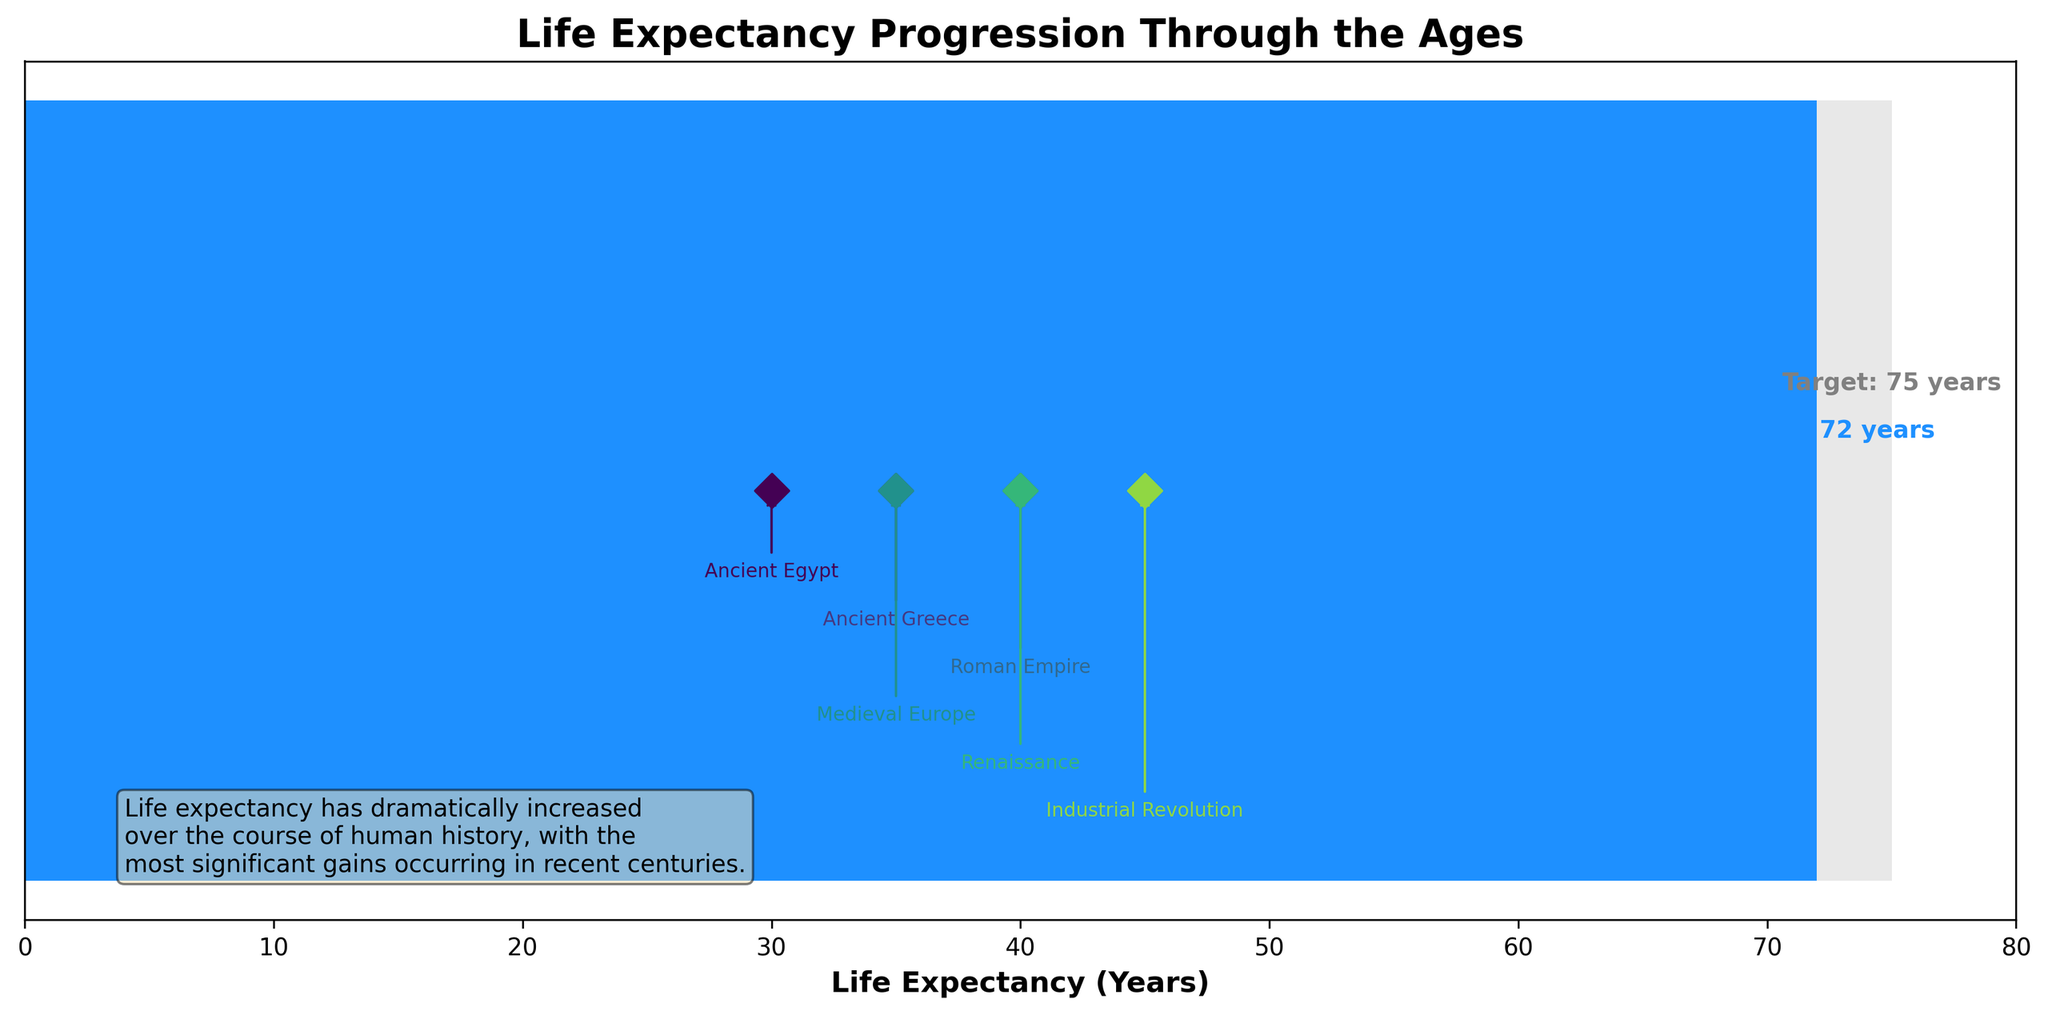What is the title of the figure? The title is located at the top of the figure, which reads "Life Expectancy Progression Through the Ages."
Answer: Life Expectancy Progression Through the Ages What is the life expectancy in the Modern Era? The Modern Era is highlighted with a blue bar, and the corresponding life expectancy value is written along the blue bar.
Answer: 72 years Which period has the highest life expectancy among the historical markers? By comparing the values marked for Ancient Egypt, Ancient Greece, Roman Empire, Medieval Europe, Renaissance, and Industrial Revolution, the highest value is seen during the Industrial Revolution.
Answer: Industrial Revolution How many historical periods are marked in the figure? The figure annotates six historical periods, indicated by different colored markers and labels along the horizontal axis.
Answer: Six What is the life expectancy target indicated in the figure? The figure uses a light grey bar to indicate the target life expectancy, and the value annotated next to this bar is 75 years.
Answer: 75 years What is the difference between the current life expectancy and the target life expectancy in the Modern Era? The current life expectancy is 72 years, and the target is 75 years. The difference is calculated by subtracting 72 from 75.
Answer: 3 years What can be inferred about the trend in life expectancy from ancient times to the modern era based on the data points? The life expectancy shows a gradual increase from ancient periods (as low as 30 years in Ancient Egypt) to modern times (72 years), indicating consistent improvements over the centuries.
Answer: Increasing trend Which historical period noted in the figure had a life expectancy of 35 years? By checking the annotations, both Ancient Greece and Medieval Europe have markers indicating a life expectancy of 35 years.
Answer: Ancient Greece, Medieval Europe How does the life expectancy in the Renaissance compare to that in the Roman Empire? Comparing the annotated markers, the Renaissance has a life expectancy of 40 years, while the Roman Empire has a life expectancy of 40 years.
Answer: Equal What is the main insight provided in the text box within the figure? The text box mentions that life expectancy has dramatically increased over the course of human history, with significant gains in recent centuries.
Answer: Increased life expectancy over time 